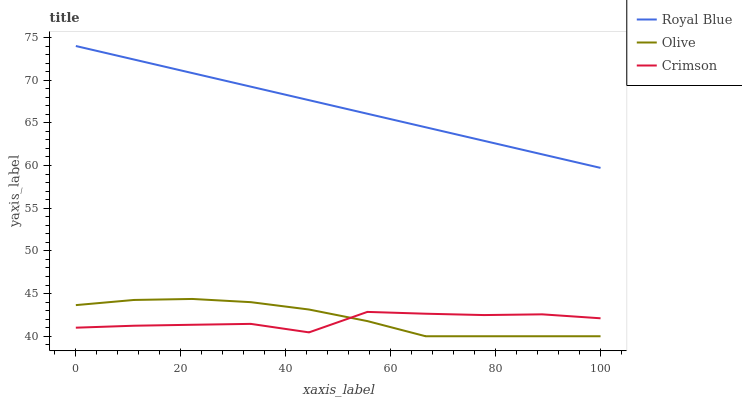Does Crimson have the minimum area under the curve?
Answer yes or no. Yes. Does Royal Blue have the maximum area under the curve?
Answer yes or no. Yes. Does Royal Blue have the minimum area under the curve?
Answer yes or no. No. Does Crimson have the maximum area under the curve?
Answer yes or no. No. Is Royal Blue the smoothest?
Answer yes or no. Yes. Is Crimson the roughest?
Answer yes or no. Yes. Is Crimson the smoothest?
Answer yes or no. No. Is Royal Blue the roughest?
Answer yes or no. No. Does Olive have the lowest value?
Answer yes or no. Yes. Does Crimson have the lowest value?
Answer yes or no. No. Does Royal Blue have the highest value?
Answer yes or no. Yes. Does Crimson have the highest value?
Answer yes or no. No. Is Olive less than Royal Blue?
Answer yes or no. Yes. Is Royal Blue greater than Crimson?
Answer yes or no. Yes. Does Olive intersect Crimson?
Answer yes or no. Yes. Is Olive less than Crimson?
Answer yes or no. No. Is Olive greater than Crimson?
Answer yes or no. No. Does Olive intersect Royal Blue?
Answer yes or no. No. 